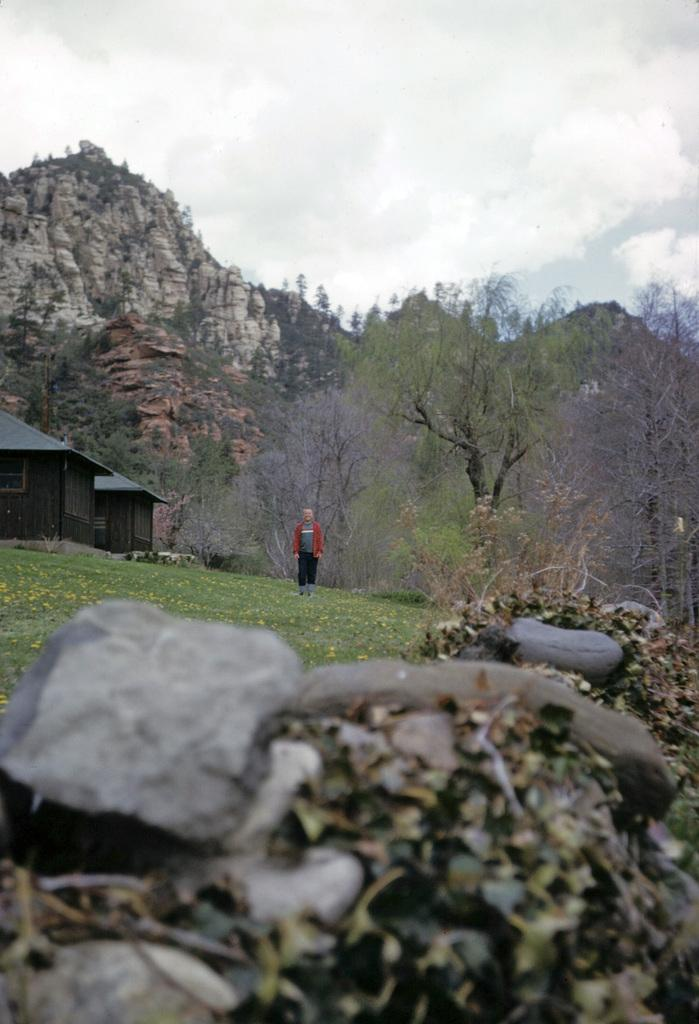What is the main subject in the image? There is a person standing in the image. What type of structures can be seen in the image? There are houses in the image. What type of vegetation is present in the image? There are plants, grass, and trees in the image. What other natural elements can be seen in the image? There are rocks and hills in the image. What is visible in the background of the image? The sky is visible in the background of the image. What type of eggnog is being served at the party in the image? There is no party or eggnog present in the image. Is the person experiencing any pain in the image? There is no indication of pain or discomfort for the person in the image. 